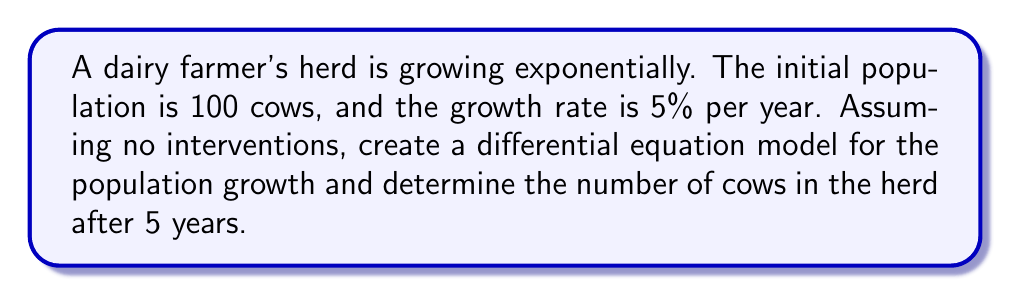Give your solution to this math problem. Let's approach this step-by-step:

1) Let $P(t)$ be the population of cows at time $t$ (in years).

2) The initial condition is $P(0) = 100$.

3) The growth rate is 5% = 0.05 per year.

4) For exponential growth, the rate of change of the population is proportional to the current population:

   $$\frac{dP}{dt} = kP$$

   where $k$ is the growth rate constant.

5) In this case, $k = 0.05$.

6) So our differential equation is:

   $$\frac{dP}{dt} = 0.05P$$

7) The general solution to this differential equation is:

   $$P(t) = Ce^{0.05t}$$

   where $C$ is a constant we need to determine.

8) Using the initial condition $P(0) = 100$:

   $100 = Ce^{0.05(0)} = C$

9) Therefore, the particular solution is:

   $$P(t) = 100e^{0.05t}$$

10) To find the population after 5 years, we evaluate $P(5)$:

    $$P(5) = 100e^{0.05(5)} = 100e^{0.25} \approx 128.40$$
Answer: The differential equation model is $\frac{dP}{dt} = 0.05P$ with $P(0) = 100$. After 5 years, the herd will have approximately 128 cows (rounded to the nearest whole cow). 